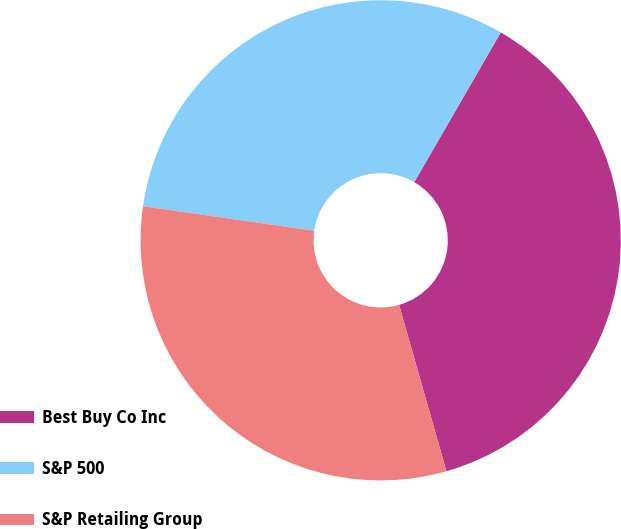Convert chart to OTSL. <chart><loc_0><loc_0><loc_500><loc_500><pie_chart><fcel>Best Buy Co Inc<fcel>S&P 500<fcel>S&P Retailing Group<nl><fcel>37.25%<fcel>31.07%<fcel>31.68%<nl></chart> 